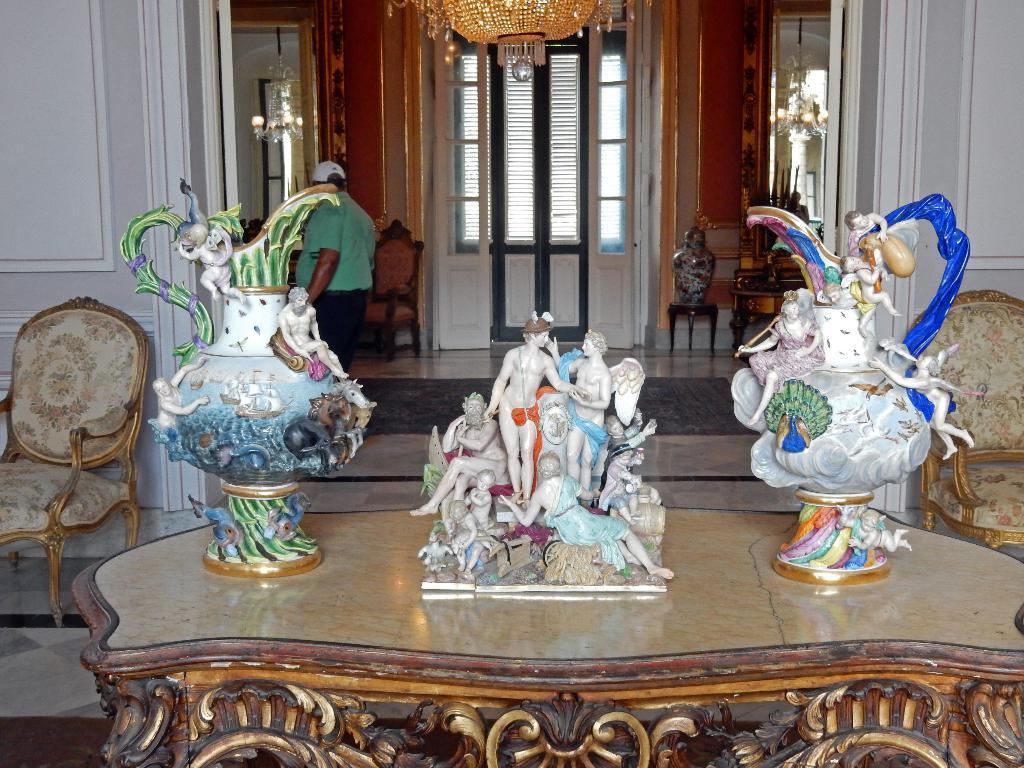Describe this image in one or two sentences. In this image i can see flower pots on the table and a statue on the table, at the back ground i can see two chairs, a man standing wearing a green shirt and a black pant and white cap, a chandelier at the top, a window and a door. 